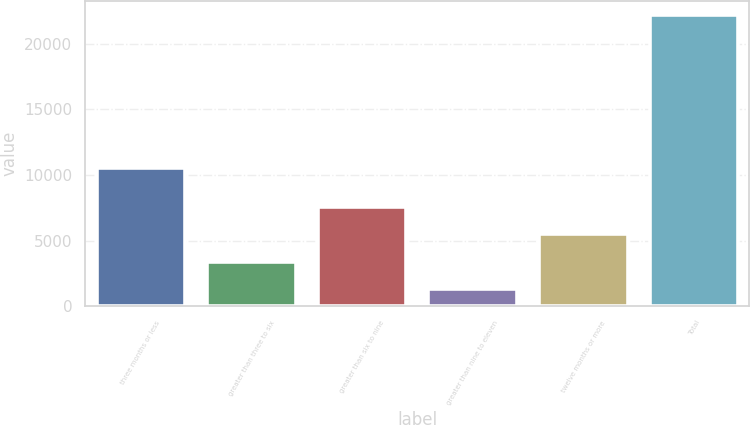Convert chart to OTSL. <chart><loc_0><loc_0><loc_500><loc_500><bar_chart><fcel>three months or less<fcel>greater than three to six<fcel>greater than six to nine<fcel>greater than nine to eleven<fcel>twelve months or more<fcel>Total<nl><fcel>10535<fcel>3388.5<fcel>7561.5<fcel>1302<fcel>5475<fcel>22167<nl></chart> 